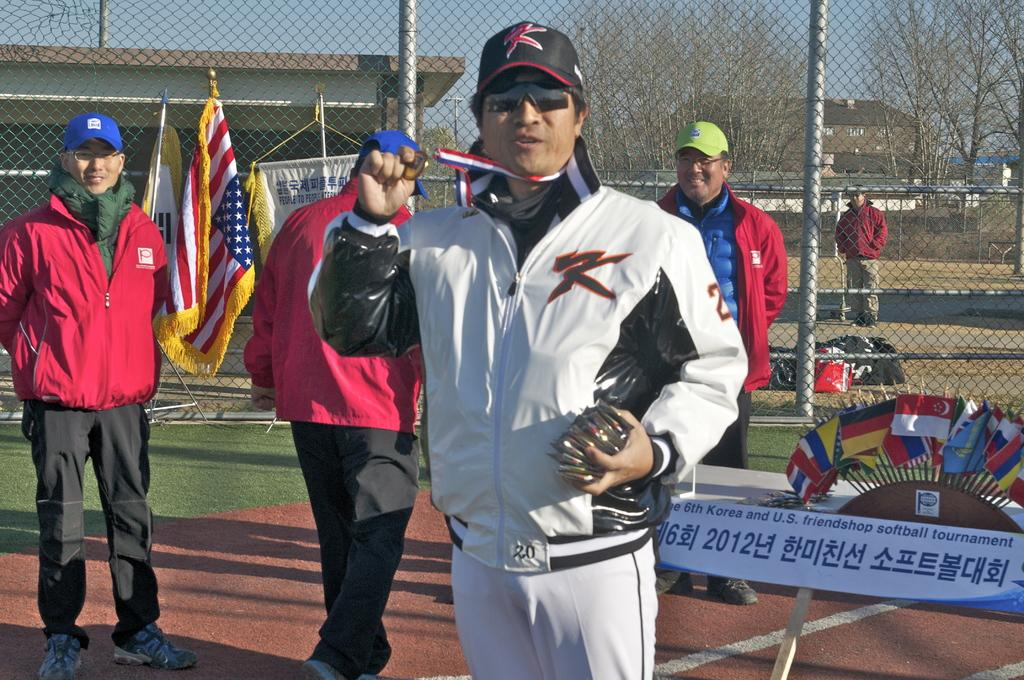<image>
Provide a brief description of the given image. Person wearing a white jacket which has the letter K on it. 